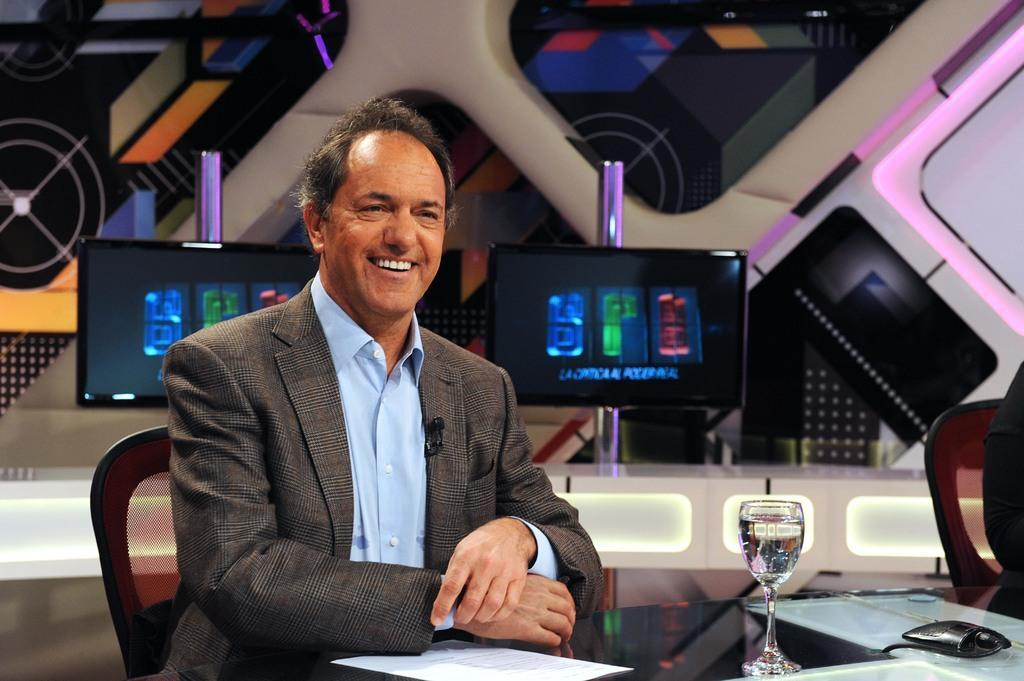In one or two sentences, can you explain what this image depicts? In this picture we can see few people, they are seated on the chairs, in front of them we can see a glass, few papers and other things on the table, in the background we can see few digital screens. 